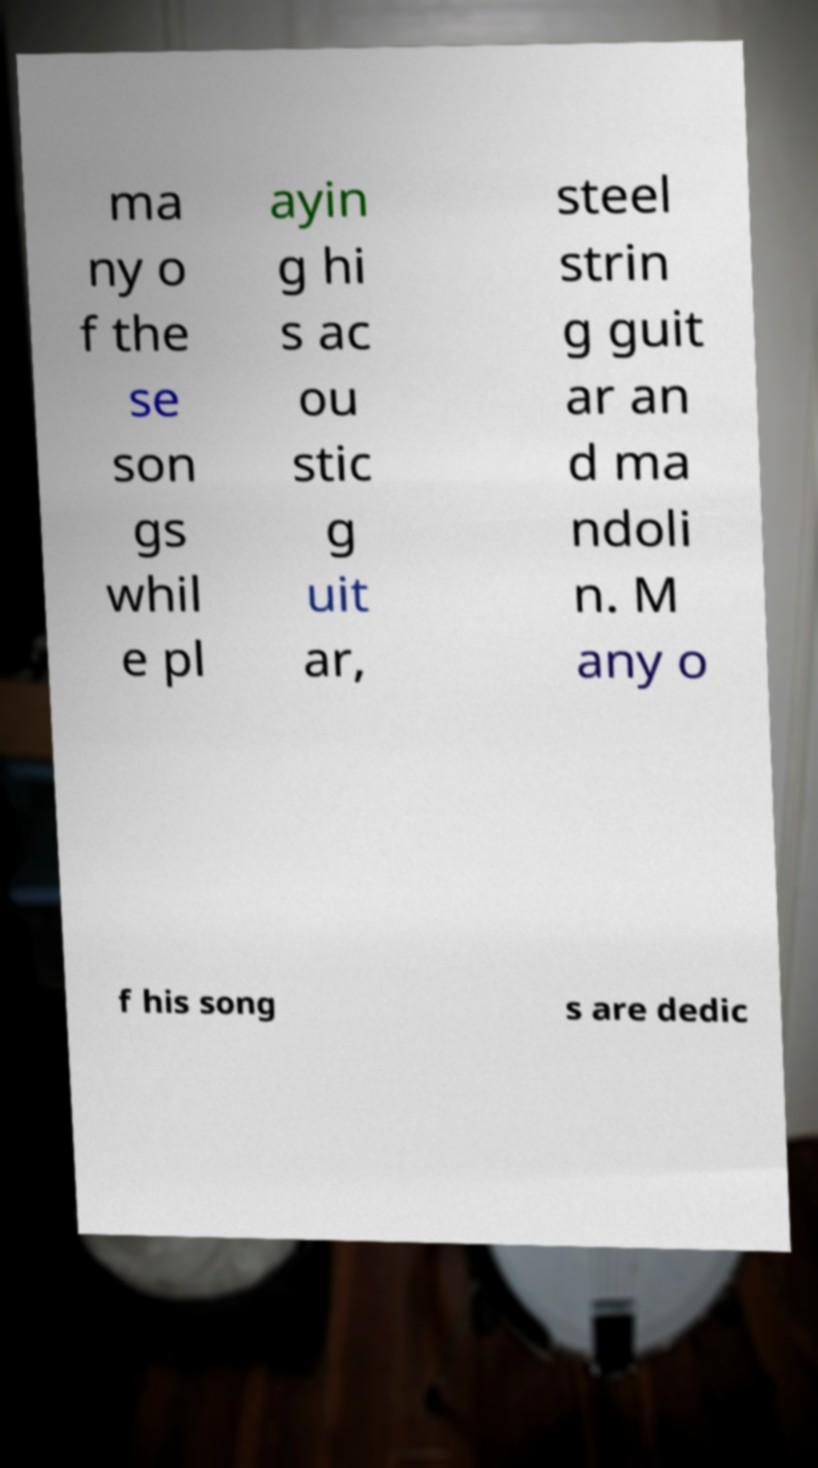For documentation purposes, I need the text within this image transcribed. Could you provide that? ma ny o f the se son gs whil e pl ayin g hi s ac ou stic g uit ar, steel strin g guit ar an d ma ndoli n. M any o f his song s are dedic 